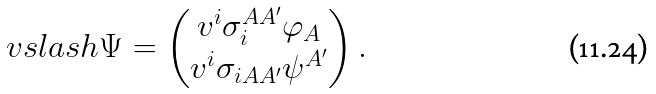Convert formula to latex. <formula><loc_0><loc_0><loc_500><loc_500>\ v s l a s h \Psi = \begin{pmatrix} v ^ { i } \sigma _ { i } ^ { A A ^ { \prime } } \varphi _ { A } \\ v ^ { i } \sigma _ { i A A ^ { \prime } } \psi ^ { A ^ { \prime } } \end{pmatrix} .</formula> 